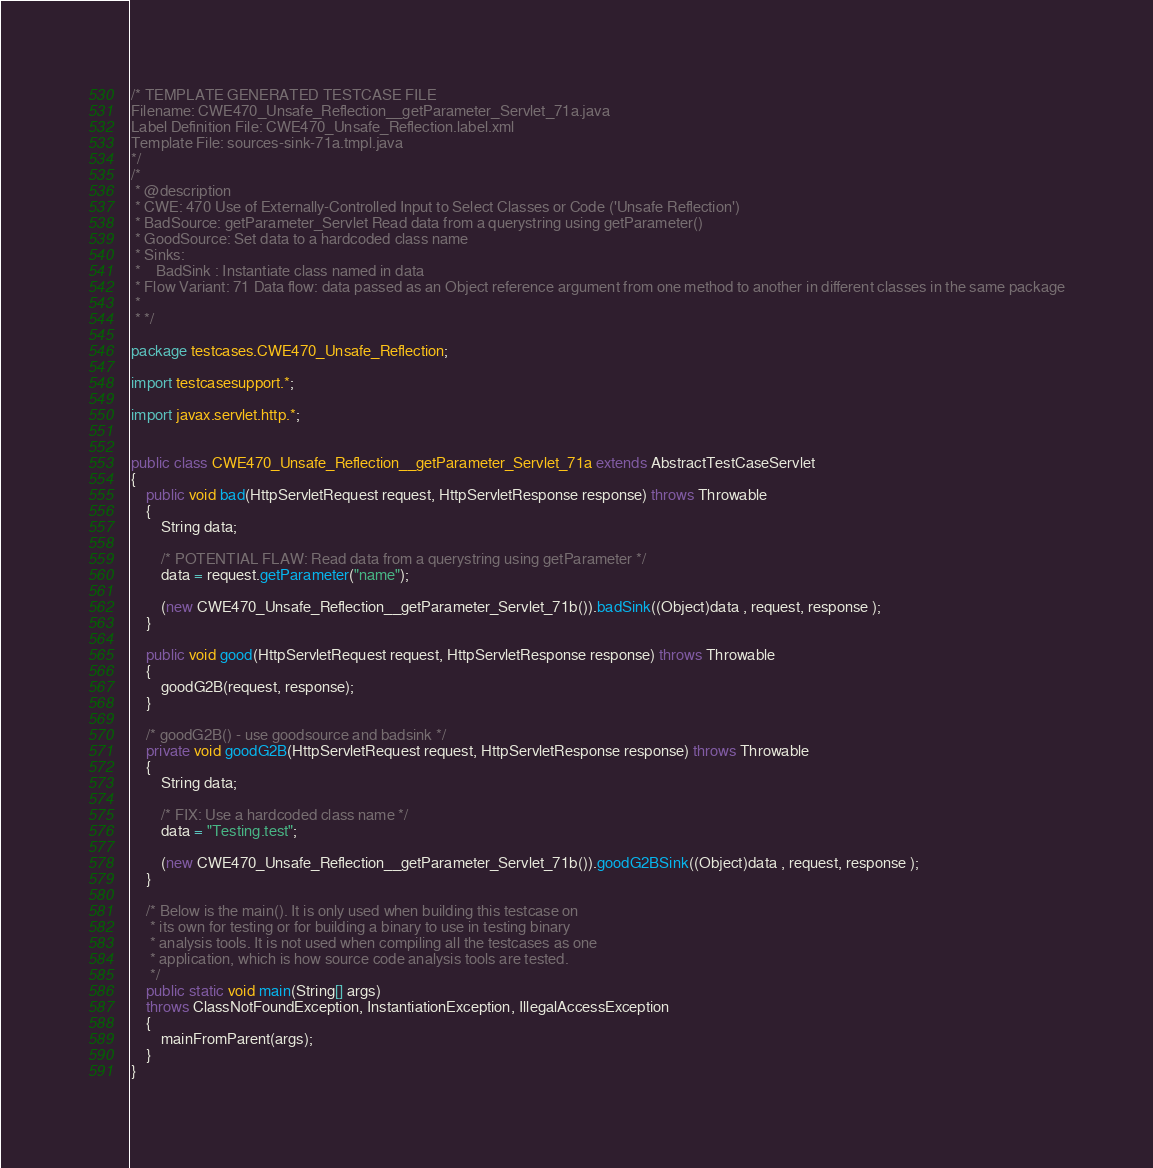<code> <loc_0><loc_0><loc_500><loc_500><_Java_>/* TEMPLATE GENERATED TESTCASE FILE
Filename: CWE470_Unsafe_Reflection__getParameter_Servlet_71a.java
Label Definition File: CWE470_Unsafe_Reflection.label.xml
Template File: sources-sink-71a.tmpl.java
*/
/*
 * @description
 * CWE: 470 Use of Externally-Controlled Input to Select Classes or Code ('Unsafe Reflection')
 * BadSource: getParameter_Servlet Read data from a querystring using getParameter()
 * GoodSource: Set data to a hardcoded class name
 * Sinks:
 *    BadSink : Instantiate class named in data
 * Flow Variant: 71 Data flow: data passed as an Object reference argument from one method to another in different classes in the same package
 *
 * */

package testcases.CWE470_Unsafe_Reflection;

import testcasesupport.*;

import javax.servlet.http.*;


public class CWE470_Unsafe_Reflection__getParameter_Servlet_71a extends AbstractTestCaseServlet
{
    public void bad(HttpServletRequest request, HttpServletResponse response) throws Throwable
    {
        String data;

        /* POTENTIAL FLAW: Read data from a querystring using getParameter */
        data = request.getParameter("name");

        (new CWE470_Unsafe_Reflection__getParameter_Servlet_71b()).badSink((Object)data , request, response );
    }

    public void good(HttpServletRequest request, HttpServletResponse response) throws Throwable
    {
        goodG2B(request, response);
    }

    /* goodG2B() - use goodsource and badsink */
    private void goodG2B(HttpServletRequest request, HttpServletResponse response) throws Throwable
    {
        String data;

        /* FIX: Use a hardcoded class name */
        data = "Testing.test";

        (new CWE470_Unsafe_Reflection__getParameter_Servlet_71b()).goodG2BSink((Object)data , request, response );
    }

    /* Below is the main(). It is only used when building this testcase on
     * its own for testing or for building a binary to use in testing binary
     * analysis tools. It is not used when compiling all the testcases as one
     * application, which is how source code analysis tools are tested.
     */
    public static void main(String[] args)
    throws ClassNotFoundException, InstantiationException, IllegalAccessException
    {
        mainFromParent(args);
    }
}
</code> 